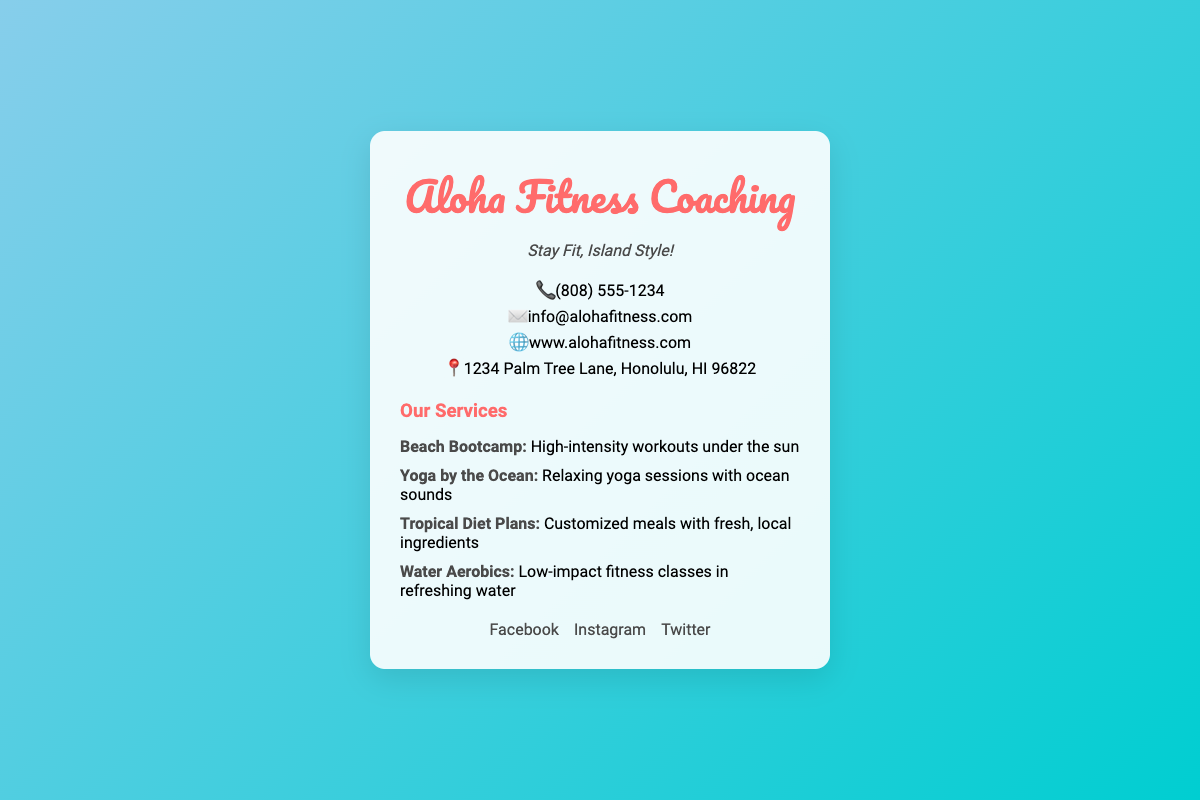What is the business name? The logo displayed prominently at the top of the card shows the name of the business.
Answer: Aloha Fitness Coaching What is the contact phone number? The contact information section lists the phone number provided for communication.
Answer: (808) 555-1234 What is the tagline? The tagline beneath the logo encapsulates the essence of the fitness coaching service offered.
Answer: Stay Fit, Island Style! What services are offered? The services section details the various types of fitness coaching provided.
Answer: Beach Bootcamp, Yoga by the Ocean, Tropical Diet Plans, Water Aerobics Where is the business located? The contact information includes the physical address of the fitness coaching business.
Answer: 1234 Palm Tree Lane, Honolulu, HI 96822 What type of fitness services does the business emphasize? The card highlights a tropical island theme, suggesting a unique workout environment.
Answer: Tropical island theme How many social media platforms are listed? The social media section provides links to different platforms for additional engagement.
Answer: Three What is the primary color theme of the card? The background gradient and logo utilize specific colors that represent the business's branding.
Answer: Blue and coral 